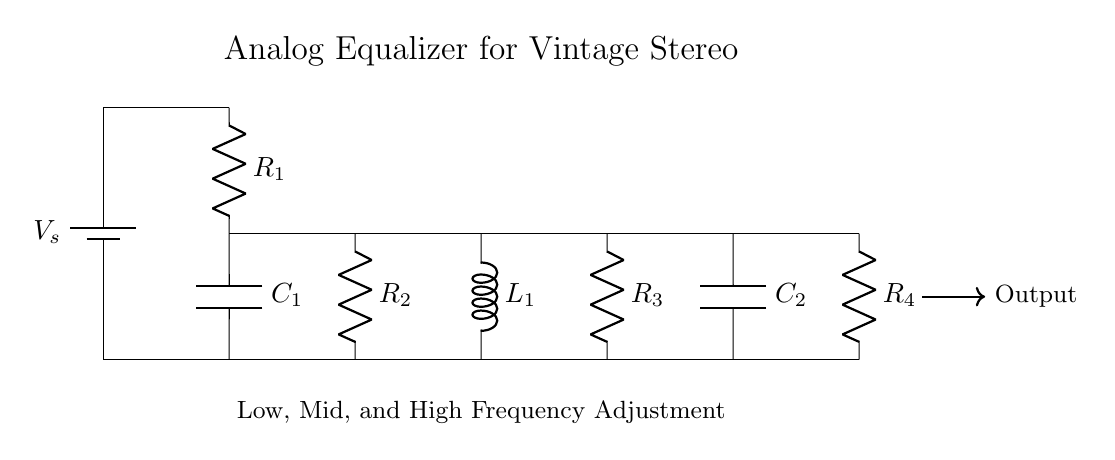What type of components are used in this circuit? The components visible in the circuit include resistors, capacitors, an inductor, and a voltage source. These components are essential for forming filters to adjust audio frequencies.
Answer: resistors, capacitors, inductor, voltage source What is the purpose of the capacitors in this circuit? Capacitors are used to block direct current while allowing alternating current to pass and are integral in frequency filtering, helping to manage low and high frequencies in the audio signal.
Answer: frequency filtering How many resistors are present in the circuit? By counting the symbols labeled R in the circuit, we can see there are four resistors, each designed to impact the audio signal's frequency characteristics differently.
Answer: four What does the inductor represent in this circuit? The inductor represents a component that resists changes in current flow and is used in combination with capacitors and resistors for shaping the frequency response of the audio signal.
Answer: frequency response shaping Which part of the circuit connects to the output? The output of the circuit is connected at the bottom right where it shows an arrow leading to the designated output node, indicating that this is where the processed audio signal emerges.
Answer: output node 